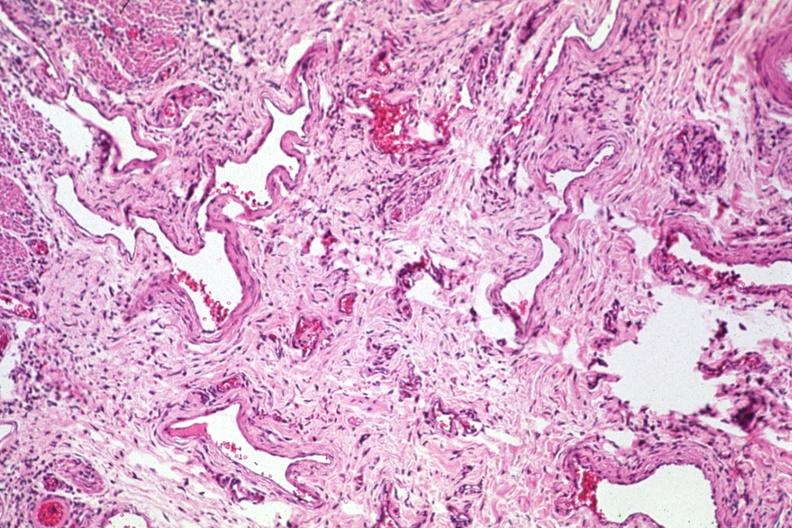s acrocyanosis present?
Answer the question using a single word or phrase. No 